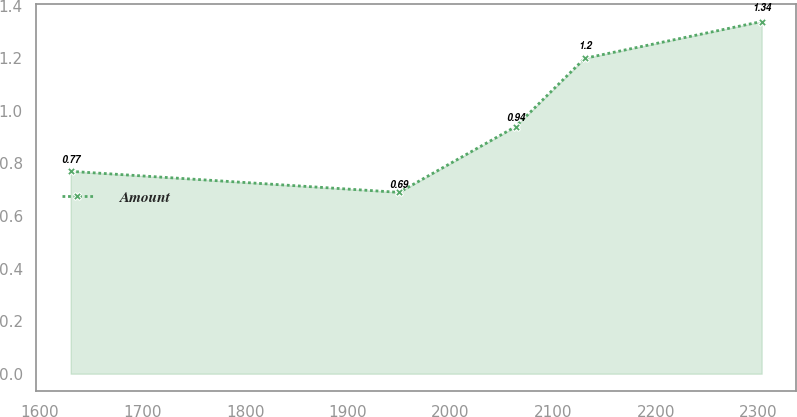Convert chart. <chart><loc_0><loc_0><loc_500><loc_500><line_chart><ecel><fcel>Amount<nl><fcel>1630.11<fcel>0.77<nl><fcel>1949.95<fcel>0.69<nl><fcel>2063.44<fcel>0.94<nl><fcel>2130.74<fcel>1.2<nl><fcel>2303.07<fcel>1.34<nl></chart> 